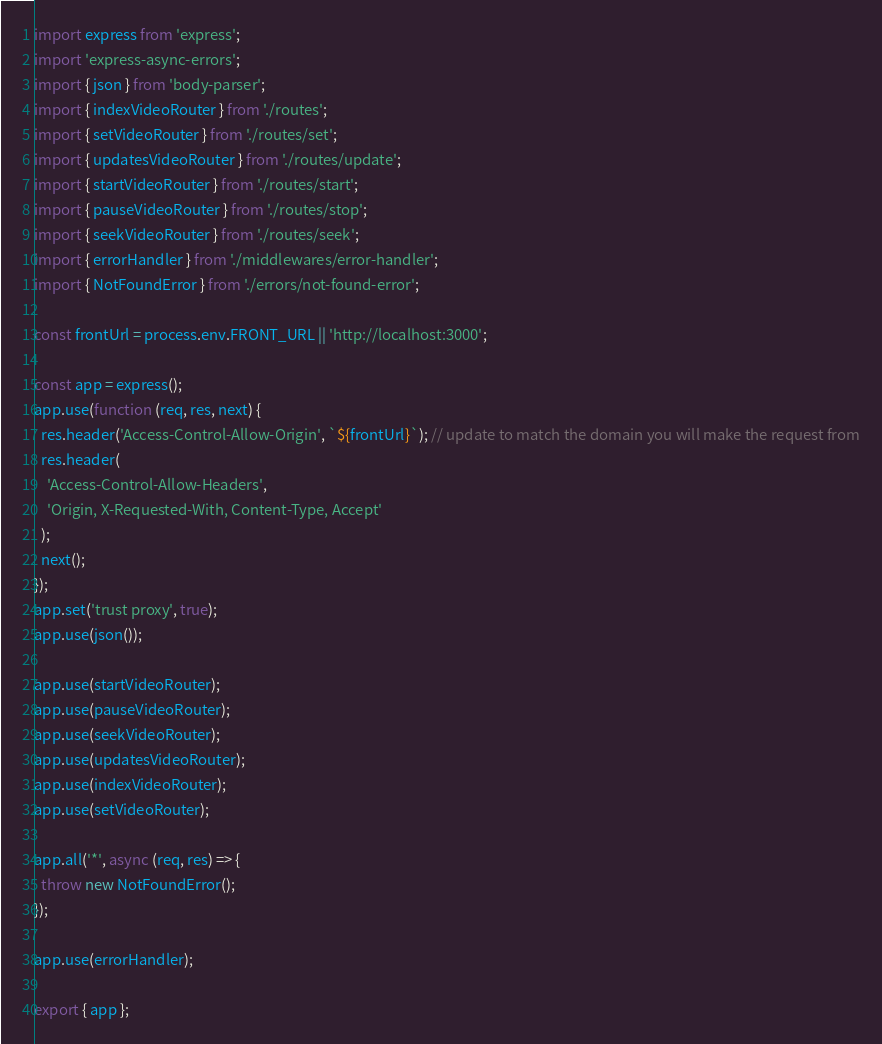Convert code to text. <code><loc_0><loc_0><loc_500><loc_500><_TypeScript_>import express from 'express';
import 'express-async-errors';
import { json } from 'body-parser';
import { indexVideoRouter } from './routes';
import { setVideoRouter } from './routes/set';
import { updatesVideoRouter } from './routes/update';
import { startVideoRouter } from './routes/start';
import { pauseVideoRouter } from './routes/stop';
import { seekVideoRouter } from './routes/seek';
import { errorHandler } from './middlewares/error-handler';
import { NotFoundError } from './errors/not-found-error';

const frontUrl = process.env.FRONT_URL || 'http://localhost:3000';

const app = express();
app.use(function (req, res, next) {
  res.header('Access-Control-Allow-Origin', `${frontUrl}`); // update to match the domain you will make the request from
  res.header(
    'Access-Control-Allow-Headers',
    'Origin, X-Requested-With, Content-Type, Accept'
  );
  next();
});
app.set('trust proxy', true);
app.use(json());

app.use(startVideoRouter);
app.use(pauseVideoRouter);
app.use(seekVideoRouter);
app.use(updatesVideoRouter);
app.use(indexVideoRouter);
app.use(setVideoRouter);

app.all('*', async (req, res) => {
  throw new NotFoundError();
});

app.use(errorHandler);

export { app };
</code> 